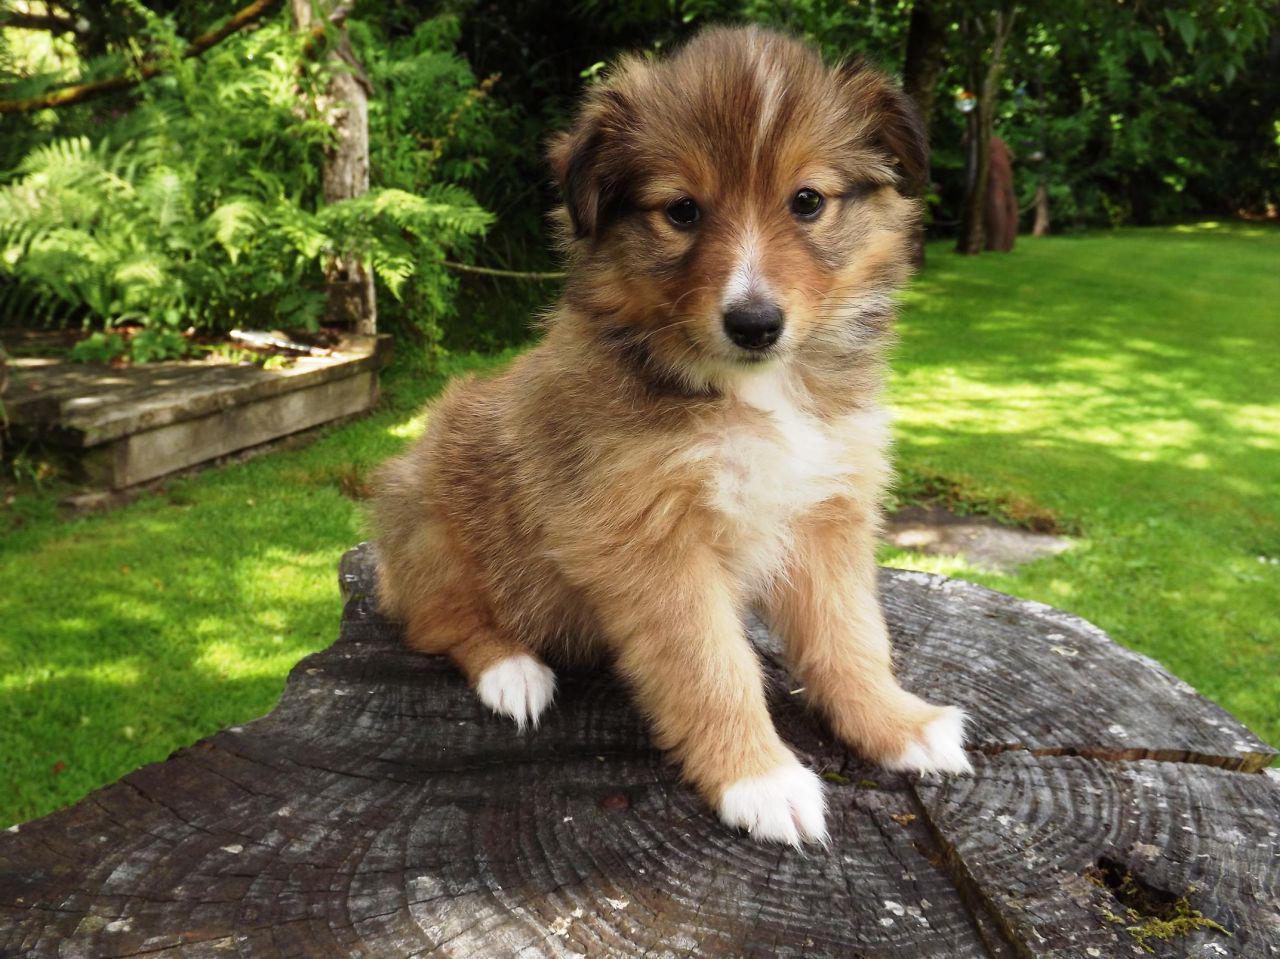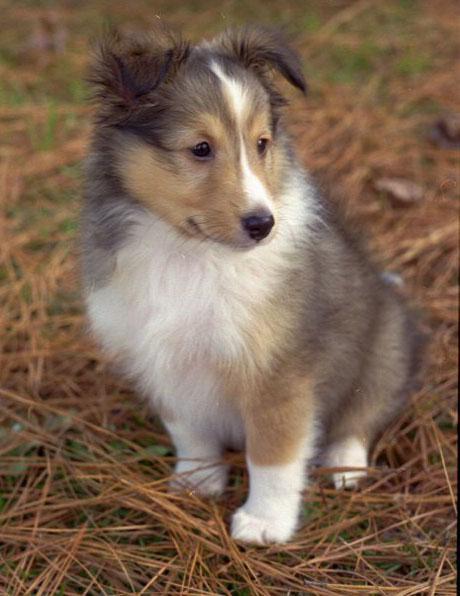The first image is the image on the left, the second image is the image on the right. For the images shown, is this caption "An image shows a young pup sitting on a cut stump." true? Answer yes or no. Yes. 